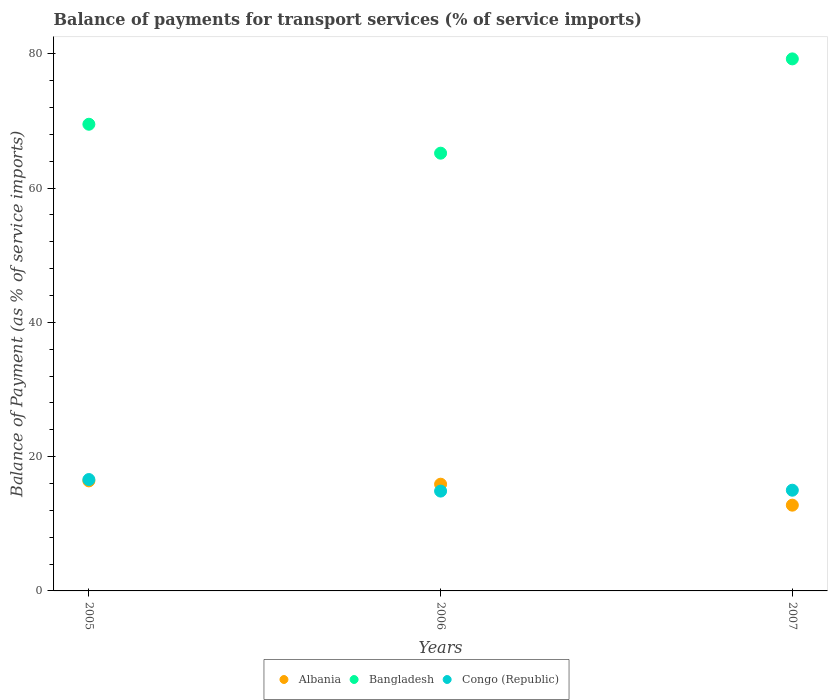How many different coloured dotlines are there?
Offer a terse response. 3. What is the balance of payments for transport services in Bangladesh in 2006?
Your response must be concise. 65.2. Across all years, what is the maximum balance of payments for transport services in Bangladesh?
Provide a succinct answer. 79.24. Across all years, what is the minimum balance of payments for transport services in Bangladesh?
Provide a succinct answer. 65.2. In which year was the balance of payments for transport services in Bangladesh minimum?
Your response must be concise. 2006. What is the total balance of payments for transport services in Albania in the graph?
Give a very brief answer. 45.06. What is the difference between the balance of payments for transport services in Bangladesh in 2006 and that in 2007?
Offer a terse response. -14.04. What is the difference between the balance of payments for transport services in Congo (Republic) in 2006 and the balance of payments for transport services in Albania in 2007?
Offer a terse response. 2.09. What is the average balance of payments for transport services in Bangladesh per year?
Give a very brief answer. 71.31. In the year 2005, what is the difference between the balance of payments for transport services in Bangladesh and balance of payments for transport services in Albania?
Keep it short and to the point. 53.12. In how many years, is the balance of payments for transport services in Bangladesh greater than 72 %?
Keep it short and to the point. 1. What is the ratio of the balance of payments for transport services in Albania in 2005 to that in 2006?
Ensure brevity in your answer.  1.03. Is the balance of payments for transport services in Bangladesh in 2005 less than that in 2007?
Your answer should be very brief. Yes. Is the difference between the balance of payments for transport services in Bangladesh in 2005 and 2007 greater than the difference between the balance of payments for transport services in Albania in 2005 and 2007?
Provide a short and direct response. No. What is the difference between the highest and the second highest balance of payments for transport services in Congo (Republic)?
Ensure brevity in your answer.  1.59. What is the difference between the highest and the lowest balance of payments for transport services in Congo (Republic)?
Your answer should be compact. 1.72. Is the sum of the balance of payments for transport services in Bangladesh in 2006 and 2007 greater than the maximum balance of payments for transport services in Congo (Republic) across all years?
Ensure brevity in your answer.  Yes. Is it the case that in every year, the sum of the balance of payments for transport services in Bangladesh and balance of payments for transport services in Albania  is greater than the balance of payments for transport services in Congo (Republic)?
Keep it short and to the point. Yes. Does the balance of payments for transport services in Bangladesh monotonically increase over the years?
Your answer should be very brief. No. Is the balance of payments for transport services in Albania strictly greater than the balance of payments for transport services in Congo (Republic) over the years?
Make the answer very short. No. How many dotlines are there?
Provide a succinct answer. 3. What is the difference between two consecutive major ticks on the Y-axis?
Offer a very short reply. 20. Where does the legend appear in the graph?
Make the answer very short. Bottom center. What is the title of the graph?
Provide a succinct answer. Balance of payments for transport services (% of service imports). What is the label or title of the X-axis?
Ensure brevity in your answer.  Years. What is the label or title of the Y-axis?
Give a very brief answer. Balance of Payment (as % of service imports). What is the Balance of Payment (as % of service imports) of Albania in 2005?
Give a very brief answer. 16.39. What is the Balance of Payment (as % of service imports) of Bangladesh in 2005?
Your answer should be compact. 69.5. What is the Balance of Payment (as % of service imports) of Congo (Republic) in 2005?
Give a very brief answer. 16.59. What is the Balance of Payment (as % of service imports) in Albania in 2006?
Provide a short and direct response. 15.9. What is the Balance of Payment (as % of service imports) in Bangladesh in 2006?
Ensure brevity in your answer.  65.2. What is the Balance of Payment (as % of service imports) in Congo (Republic) in 2006?
Your answer should be compact. 14.87. What is the Balance of Payment (as % of service imports) in Albania in 2007?
Your answer should be very brief. 12.77. What is the Balance of Payment (as % of service imports) of Bangladesh in 2007?
Ensure brevity in your answer.  79.24. What is the Balance of Payment (as % of service imports) of Congo (Republic) in 2007?
Ensure brevity in your answer.  15. Across all years, what is the maximum Balance of Payment (as % of service imports) in Albania?
Keep it short and to the point. 16.39. Across all years, what is the maximum Balance of Payment (as % of service imports) of Bangladesh?
Make the answer very short. 79.24. Across all years, what is the maximum Balance of Payment (as % of service imports) of Congo (Republic)?
Give a very brief answer. 16.59. Across all years, what is the minimum Balance of Payment (as % of service imports) of Albania?
Ensure brevity in your answer.  12.77. Across all years, what is the minimum Balance of Payment (as % of service imports) of Bangladesh?
Your answer should be very brief. 65.2. Across all years, what is the minimum Balance of Payment (as % of service imports) in Congo (Republic)?
Ensure brevity in your answer.  14.87. What is the total Balance of Payment (as % of service imports) of Albania in the graph?
Your answer should be very brief. 45.06. What is the total Balance of Payment (as % of service imports) of Bangladesh in the graph?
Provide a short and direct response. 213.94. What is the total Balance of Payment (as % of service imports) in Congo (Republic) in the graph?
Ensure brevity in your answer.  46.46. What is the difference between the Balance of Payment (as % of service imports) of Albania in 2005 and that in 2006?
Make the answer very short. 0.49. What is the difference between the Balance of Payment (as % of service imports) of Bangladesh in 2005 and that in 2006?
Offer a very short reply. 4.31. What is the difference between the Balance of Payment (as % of service imports) of Congo (Republic) in 2005 and that in 2006?
Provide a succinct answer. 1.72. What is the difference between the Balance of Payment (as % of service imports) in Albania in 2005 and that in 2007?
Offer a terse response. 3.61. What is the difference between the Balance of Payment (as % of service imports) of Bangladesh in 2005 and that in 2007?
Offer a terse response. -9.74. What is the difference between the Balance of Payment (as % of service imports) in Congo (Republic) in 2005 and that in 2007?
Offer a terse response. 1.59. What is the difference between the Balance of Payment (as % of service imports) in Albania in 2006 and that in 2007?
Provide a short and direct response. 3.12. What is the difference between the Balance of Payment (as % of service imports) in Bangladesh in 2006 and that in 2007?
Make the answer very short. -14.04. What is the difference between the Balance of Payment (as % of service imports) in Congo (Republic) in 2006 and that in 2007?
Your answer should be very brief. -0.13. What is the difference between the Balance of Payment (as % of service imports) in Albania in 2005 and the Balance of Payment (as % of service imports) in Bangladesh in 2006?
Your response must be concise. -48.81. What is the difference between the Balance of Payment (as % of service imports) in Albania in 2005 and the Balance of Payment (as % of service imports) in Congo (Republic) in 2006?
Offer a terse response. 1.52. What is the difference between the Balance of Payment (as % of service imports) of Bangladesh in 2005 and the Balance of Payment (as % of service imports) of Congo (Republic) in 2006?
Keep it short and to the point. 54.64. What is the difference between the Balance of Payment (as % of service imports) of Albania in 2005 and the Balance of Payment (as % of service imports) of Bangladesh in 2007?
Your answer should be very brief. -62.85. What is the difference between the Balance of Payment (as % of service imports) of Albania in 2005 and the Balance of Payment (as % of service imports) of Congo (Republic) in 2007?
Offer a very short reply. 1.39. What is the difference between the Balance of Payment (as % of service imports) of Bangladesh in 2005 and the Balance of Payment (as % of service imports) of Congo (Republic) in 2007?
Offer a very short reply. 54.51. What is the difference between the Balance of Payment (as % of service imports) of Albania in 2006 and the Balance of Payment (as % of service imports) of Bangladesh in 2007?
Offer a terse response. -63.34. What is the difference between the Balance of Payment (as % of service imports) of Albania in 2006 and the Balance of Payment (as % of service imports) of Congo (Republic) in 2007?
Provide a short and direct response. 0.9. What is the difference between the Balance of Payment (as % of service imports) in Bangladesh in 2006 and the Balance of Payment (as % of service imports) in Congo (Republic) in 2007?
Give a very brief answer. 50.2. What is the average Balance of Payment (as % of service imports) of Albania per year?
Offer a terse response. 15.02. What is the average Balance of Payment (as % of service imports) of Bangladesh per year?
Offer a terse response. 71.31. What is the average Balance of Payment (as % of service imports) in Congo (Republic) per year?
Ensure brevity in your answer.  15.49. In the year 2005, what is the difference between the Balance of Payment (as % of service imports) of Albania and Balance of Payment (as % of service imports) of Bangladesh?
Your response must be concise. -53.12. In the year 2005, what is the difference between the Balance of Payment (as % of service imports) in Albania and Balance of Payment (as % of service imports) in Congo (Republic)?
Keep it short and to the point. -0.2. In the year 2005, what is the difference between the Balance of Payment (as % of service imports) in Bangladesh and Balance of Payment (as % of service imports) in Congo (Republic)?
Ensure brevity in your answer.  52.92. In the year 2006, what is the difference between the Balance of Payment (as % of service imports) in Albania and Balance of Payment (as % of service imports) in Bangladesh?
Give a very brief answer. -49.3. In the year 2006, what is the difference between the Balance of Payment (as % of service imports) in Albania and Balance of Payment (as % of service imports) in Congo (Republic)?
Give a very brief answer. 1.03. In the year 2006, what is the difference between the Balance of Payment (as % of service imports) in Bangladesh and Balance of Payment (as % of service imports) in Congo (Republic)?
Ensure brevity in your answer.  50.33. In the year 2007, what is the difference between the Balance of Payment (as % of service imports) of Albania and Balance of Payment (as % of service imports) of Bangladesh?
Your answer should be very brief. -66.47. In the year 2007, what is the difference between the Balance of Payment (as % of service imports) of Albania and Balance of Payment (as % of service imports) of Congo (Republic)?
Make the answer very short. -2.23. In the year 2007, what is the difference between the Balance of Payment (as % of service imports) in Bangladesh and Balance of Payment (as % of service imports) in Congo (Republic)?
Your response must be concise. 64.24. What is the ratio of the Balance of Payment (as % of service imports) of Albania in 2005 to that in 2006?
Make the answer very short. 1.03. What is the ratio of the Balance of Payment (as % of service imports) of Bangladesh in 2005 to that in 2006?
Your response must be concise. 1.07. What is the ratio of the Balance of Payment (as % of service imports) in Congo (Republic) in 2005 to that in 2006?
Your answer should be very brief. 1.12. What is the ratio of the Balance of Payment (as % of service imports) of Albania in 2005 to that in 2007?
Ensure brevity in your answer.  1.28. What is the ratio of the Balance of Payment (as % of service imports) in Bangladesh in 2005 to that in 2007?
Provide a short and direct response. 0.88. What is the ratio of the Balance of Payment (as % of service imports) in Congo (Republic) in 2005 to that in 2007?
Offer a very short reply. 1.11. What is the ratio of the Balance of Payment (as % of service imports) of Albania in 2006 to that in 2007?
Give a very brief answer. 1.24. What is the ratio of the Balance of Payment (as % of service imports) in Bangladesh in 2006 to that in 2007?
Keep it short and to the point. 0.82. What is the ratio of the Balance of Payment (as % of service imports) in Congo (Republic) in 2006 to that in 2007?
Ensure brevity in your answer.  0.99. What is the difference between the highest and the second highest Balance of Payment (as % of service imports) in Albania?
Give a very brief answer. 0.49. What is the difference between the highest and the second highest Balance of Payment (as % of service imports) of Bangladesh?
Make the answer very short. 9.74. What is the difference between the highest and the second highest Balance of Payment (as % of service imports) in Congo (Republic)?
Offer a very short reply. 1.59. What is the difference between the highest and the lowest Balance of Payment (as % of service imports) of Albania?
Provide a succinct answer. 3.61. What is the difference between the highest and the lowest Balance of Payment (as % of service imports) of Bangladesh?
Your response must be concise. 14.04. What is the difference between the highest and the lowest Balance of Payment (as % of service imports) of Congo (Republic)?
Offer a very short reply. 1.72. 